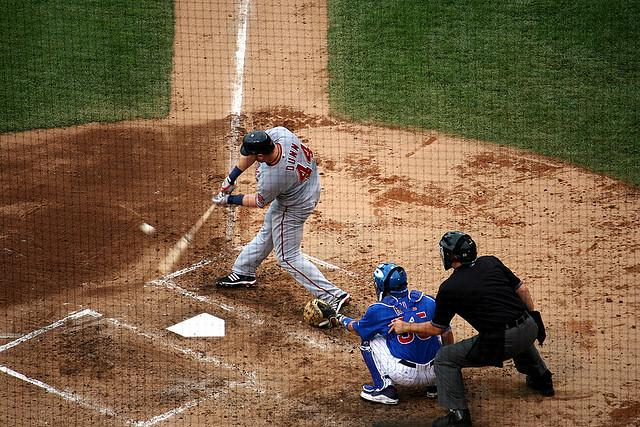What is number 44 doing? Please explain your reasoning. swinging bat. The man in the number 44 shirt is standing still and the ball has not been hit but he is trying to hit it 